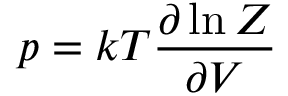Convert formula to latex. <formula><loc_0><loc_0><loc_500><loc_500>p = k T { \frac { \partial \ln Z } { \partial V } }</formula> 